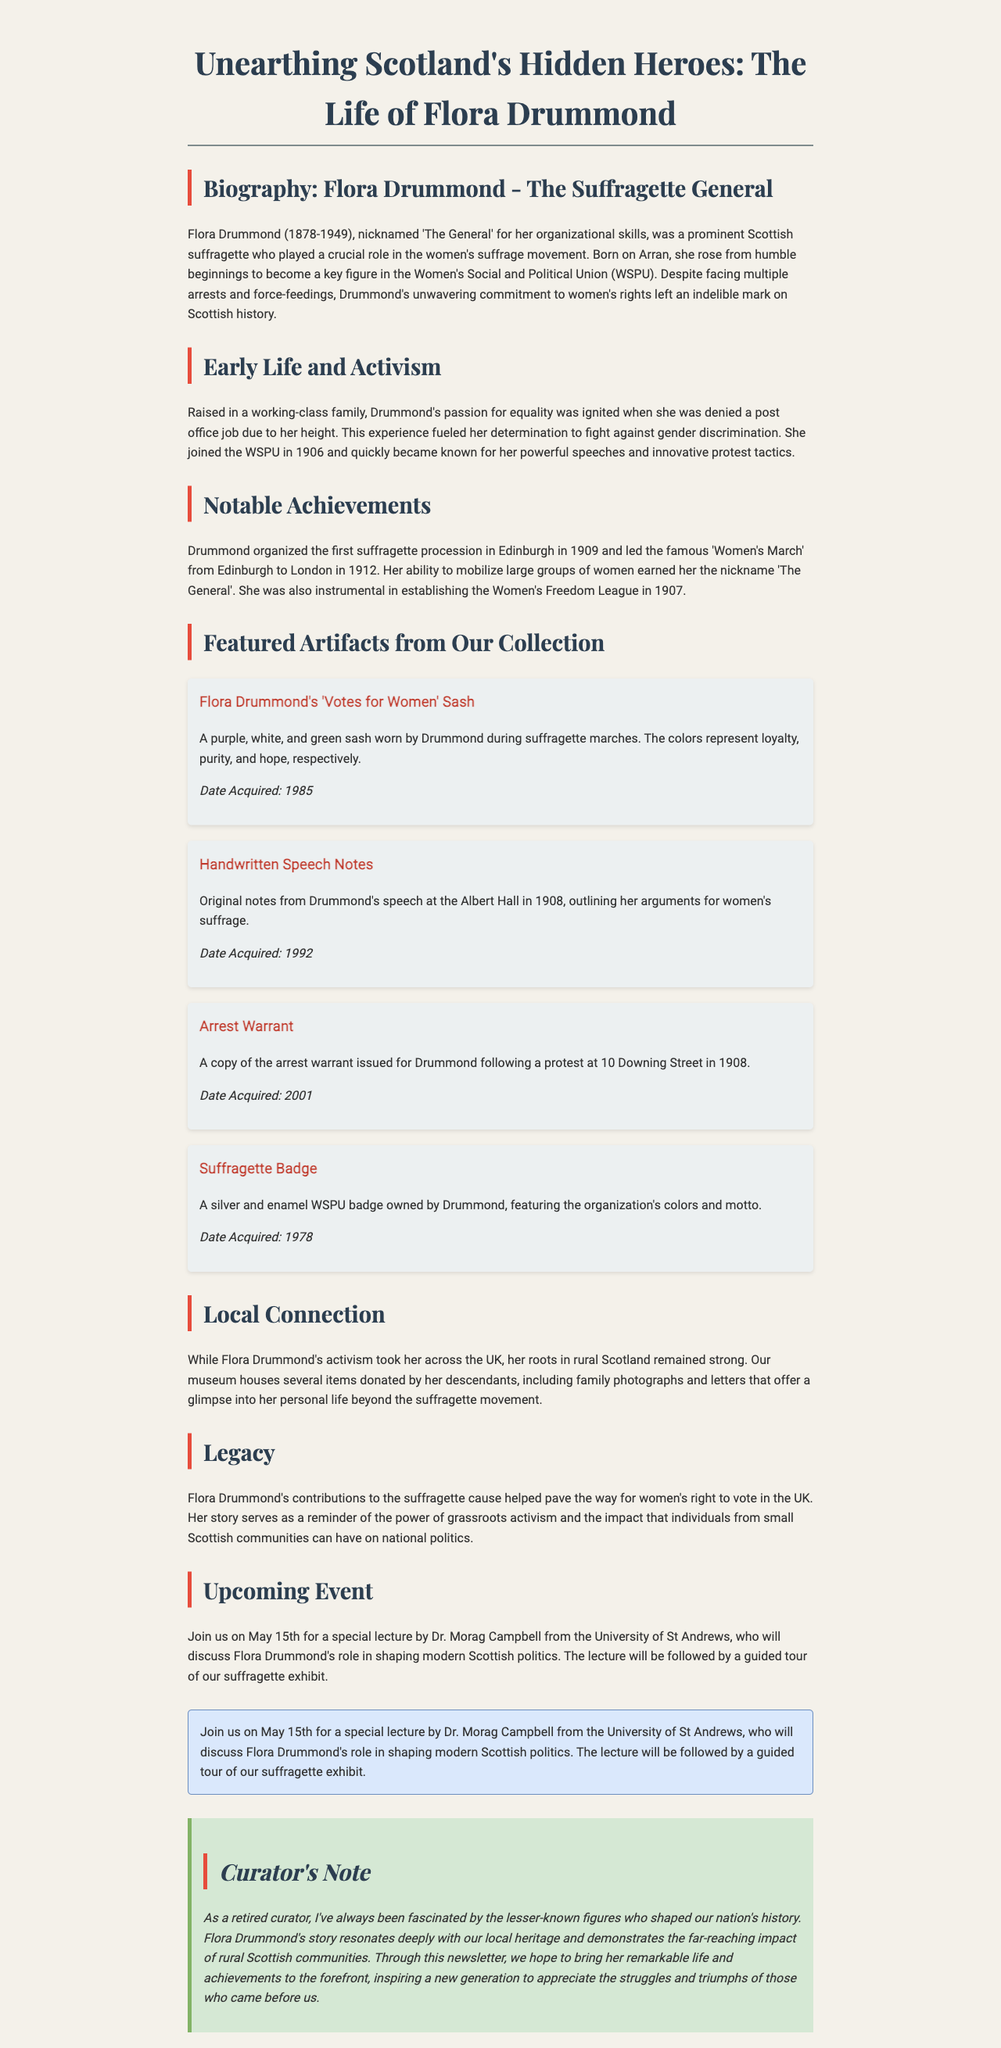What is Flora Drummond's nickname? Flora Drummond is referred to as 'The General' due to her organizational skills in activism.
Answer: 'The General' In what year was the first suffragette procession in Edinburgh organized? Flora Drummond organized the first suffragette procession in Edinburgh in 1909.
Answer: 1909 What were the colors of the 'Votes for Women' sash? The sash represented loyalty, purity, and hope with its purple, white, and green colors.
Answer: purple, white, and green What is the date of the upcoming lecture about Flora Drummond? The upcoming lecture will take place on May 15th.
Answer: May 15th What organization did Flora Drummond help establish in 1907? She was instrumental in establishing the Women's Freedom League in 1907.
Answer: Women's Freedom League How many artifacts from Flora Drummond are featured in the museum collection? The document mentions four artifacts related to Flora Drummond's activism.
Answer: four In which year was Flora Drummond's arrest warrant acquired by the museum? The arrest warrant was acquired in 2001.
Answer: 2001 What is the significance of Flora Drummond's contributions as depicted in the newsletter? Her contributions helped pave the way for women's right to vote in the UK.
Answer: women's right to vote 